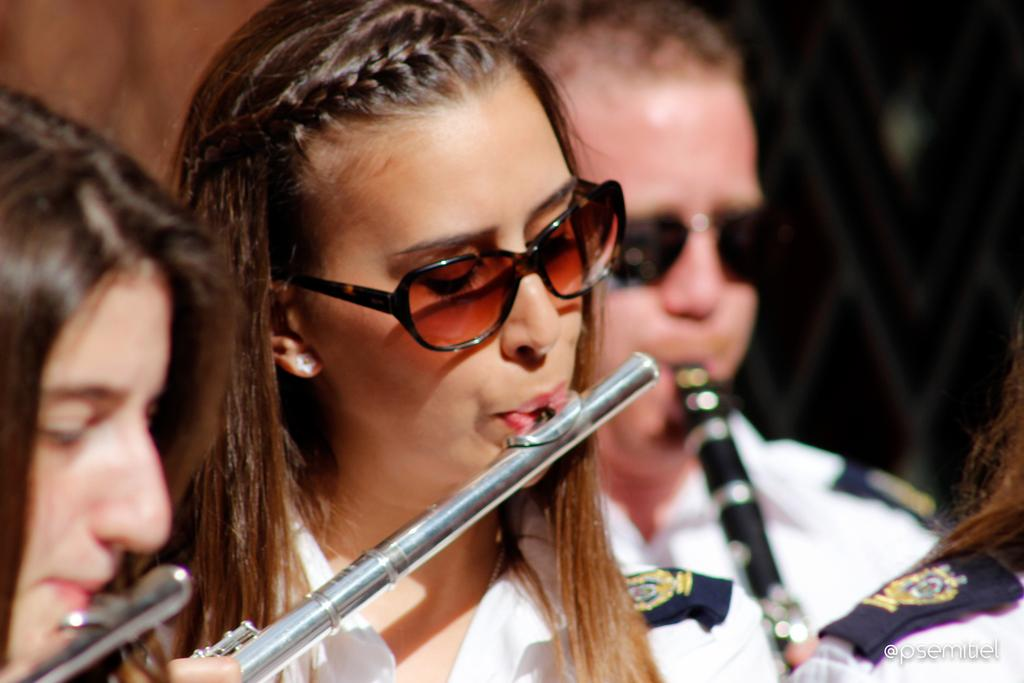How many people are in the image? There are persons in the image. What are the persons doing in the image? The persons are playing the flute. What type of sand can be seen on the tray in the image? There is no sand or tray present in the image; the persons are playing the flute. What direction are the persons pointing in the image? The provided facts do not mention any pointing or directions, as the focus is on the persons playing the flute. 